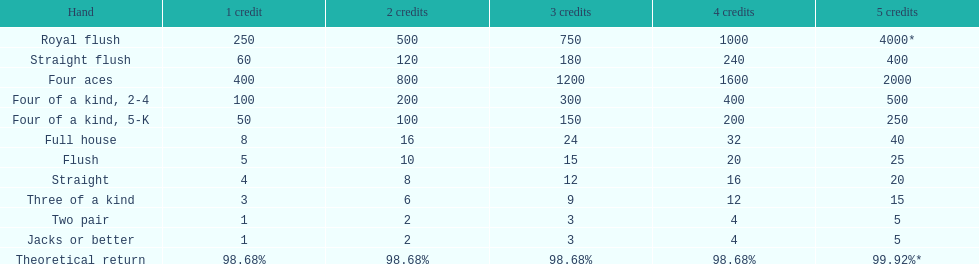After winning on four credits with a full house, what is your payout? 32. 